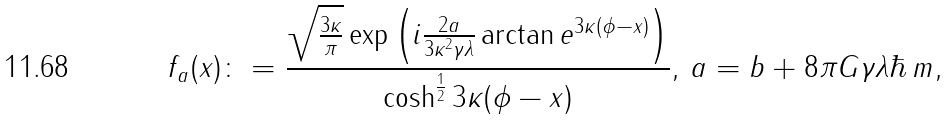Convert formula to latex. <formula><loc_0><loc_0><loc_500><loc_500>f _ { a } ( x ) \colon = \frac { \sqrt { \frac { 3 \kappa } { \pi } } \exp \left ( i \frac { 2 a } { 3 \kappa ^ { 2 } \gamma \lambda } \arctan e ^ { 3 \kappa ( \phi - x ) } \right ) } { \cosh ^ { \frac { 1 } { 2 } } 3 \kappa ( \phi - x ) } , \, a = b + 8 \pi G \gamma \lambda \hbar { \, } m ,</formula> 